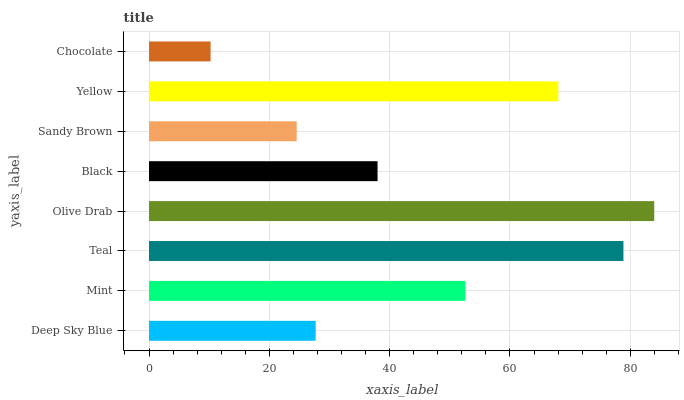Is Chocolate the minimum?
Answer yes or no. Yes. Is Olive Drab the maximum?
Answer yes or no. Yes. Is Mint the minimum?
Answer yes or no. No. Is Mint the maximum?
Answer yes or no. No. Is Mint greater than Deep Sky Blue?
Answer yes or no. Yes. Is Deep Sky Blue less than Mint?
Answer yes or no. Yes. Is Deep Sky Blue greater than Mint?
Answer yes or no. No. Is Mint less than Deep Sky Blue?
Answer yes or no. No. Is Mint the high median?
Answer yes or no. Yes. Is Black the low median?
Answer yes or no. Yes. Is Chocolate the high median?
Answer yes or no. No. Is Mint the low median?
Answer yes or no. No. 